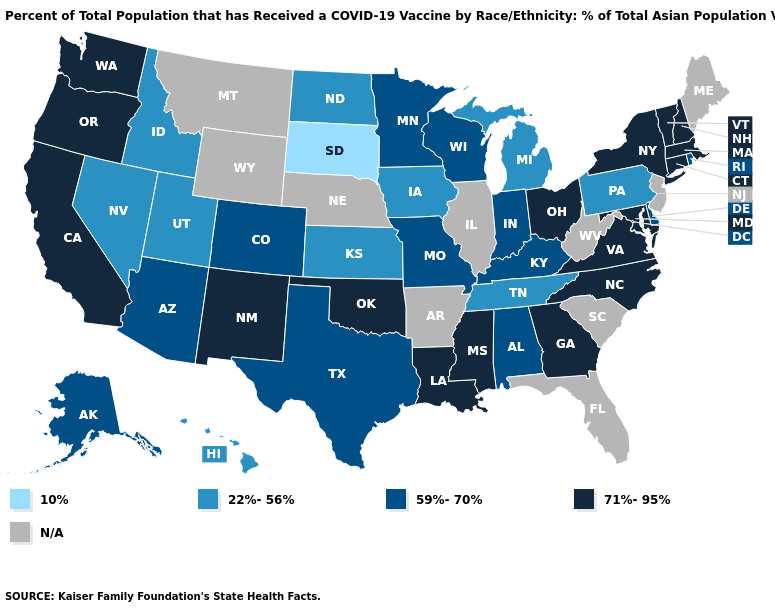Which states have the lowest value in the USA?
Answer briefly. South Dakota. What is the value of New York?
Quick response, please. 71%-95%. Name the states that have a value in the range 71%-95%?
Be succinct. California, Connecticut, Georgia, Louisiana, Maryland, Massachusetts, Mississippi, New Hampshire, New Mexico, New York, North Carolina, Ohio, Oklahoma, Oregon, Vermont, Virginia, Washington. What is the highest value in states that border Maine?
Short answer required. 71%-95%. Among the states that border New York , does Connecticut have the lowest value?
Answer briefly. No. What is the value of Arkansas?
Be succinct. N/A. Does the map have missing data?
Concise answer only. Yes. What is the lowest value in the Northeast?
Write a very short answer. 22%-56%. Does Arizona have the highest value in the USA?
Answer briefly. No. Among the states that border Massachusetts , which have the highest value?
Short answer required. Connecticut, New Hampshire, New York, Vermont. What is the value of Oklahoma?
Write a very short answer. 71%-95%. What is the highest value in states that border Illinois?
Quick response, please. 59%-70%. What is the value of Minnesota?
Answer briefly. 59%-70%. What is the highest value in the West ?
Concise answer only. 71%-95%. 